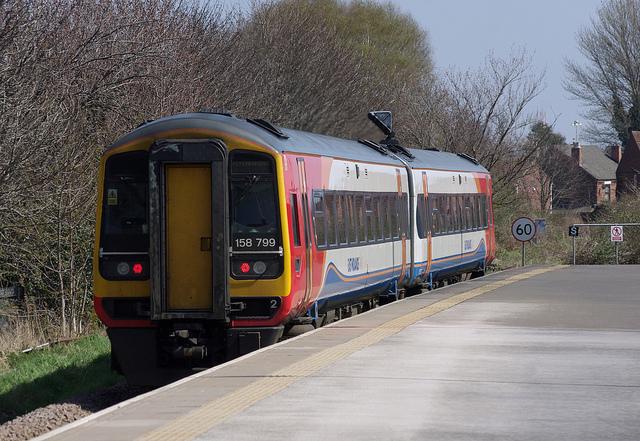Do you see graffiti?
Write a very short answer. No. Are the doors closed?
Be succinct. Yes. Is the picture black and white?
Keep it brief. No. What is the number on the train?
Answer briefly. 158799. Are the colors in this scene true to life?
Concise answer only. Yes. What number is on the circular sign in the background?
Concise answer only. 60. Is the train moving?
Write a very short answer. Yes. What number is on the train?
Keep it brief. 158 799. Is there a man standing beside the train?
Write a very short answer. No. Is it Autumn?
Keep it brief. Yes. Is this a passenger train?
Be succinct. Yes. 